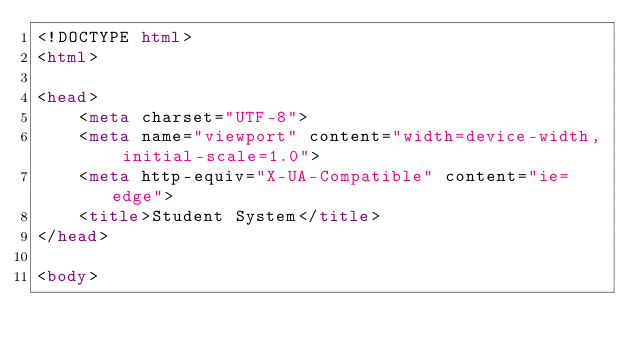<code> <loc_0><loc_0><loc_500><loc_500><_HTML_><!DOCTYPE html>
<html>

<head>
    <meta charset="UTF-8">
    <meta name="viewport" content="width=device-width, initial-scale=1.0">
    <meta http-equiv="X-UA-Compatible" content="ie=edge">
    <title>Student System</title>
</head>

<body></code> 